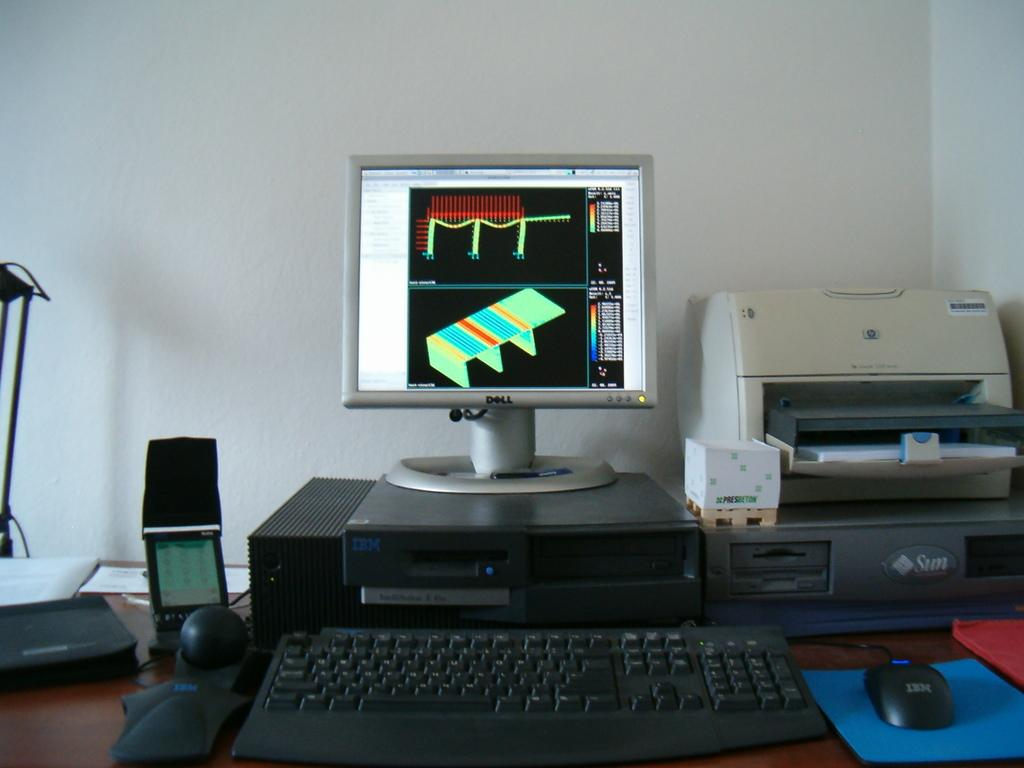What type of furniture is present in the image? There is a desktop in the image. What is placed on the desktop? There is a keyboard, a mouse, and a printer on the desktop. Where are these objects located? All these objects are on a table. What can be seen in the background of the image? There is a wall visible in the background of the image. What type of pies are being baked by the engine in the image? There is no engine or pies present in the image; it features a desktop with a keyboard, mouse, and printer on a table. 